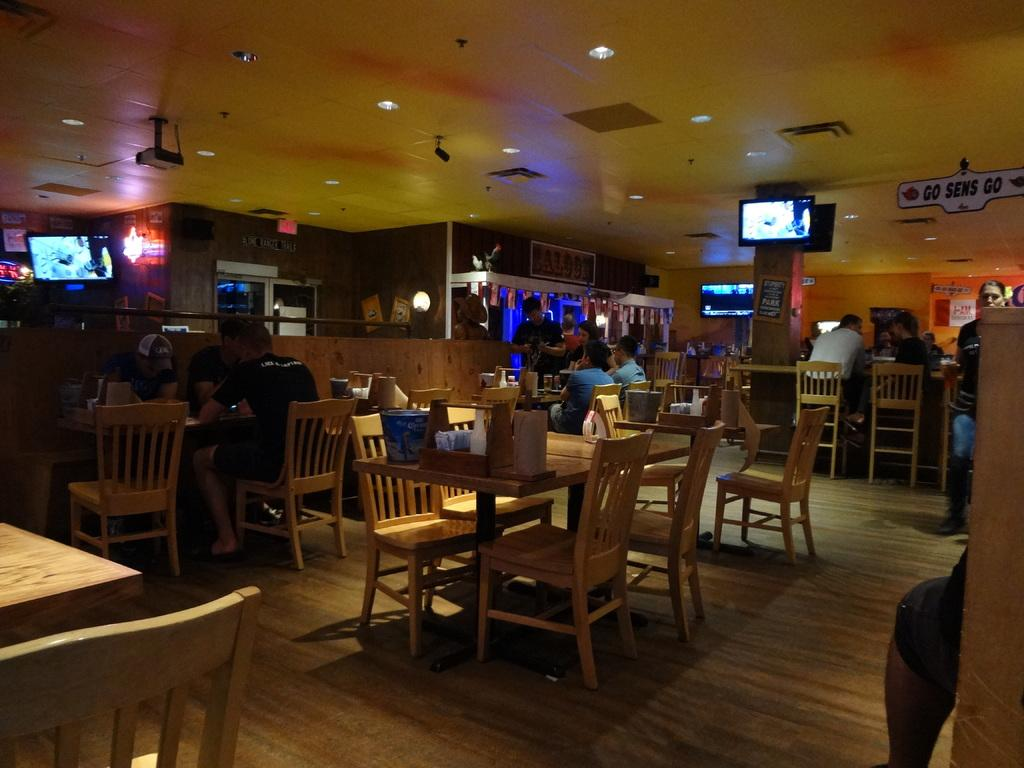What type of space is depicted in the image? There is a room in the image. What furniture is present in the room? The room contains chairs and a table. What is on the table in the room? There are items on the table. What are the people in the room doing? People are sitting on the chairs. What type of visual display devices are in the room? There are two screens in the room. What type of rhythm is being played on the hammer in the image? There is no hammer present in the image, so it is not possible to determine the rhythm being played. 